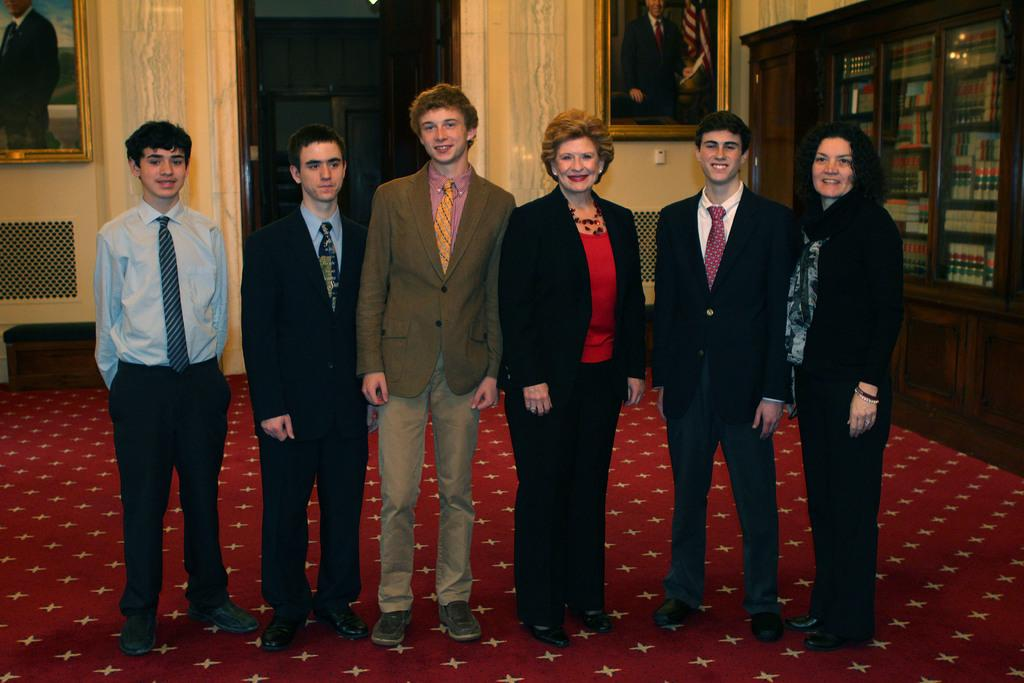Who or what is present in the image? There are people in the image. What is the facial expression of the people in the image? The people in the image are smiling. What can be seen on the back of the image? There are photo frames on the back. What type of items can be found in the cupboard? There are books in a cupboard. What is covering the floor in the image? There is a carpet on the floor. What type of wine is being served in the image? There is no wine present in the image. What industry is depicted in the image? The image does not depict any specific industry. 